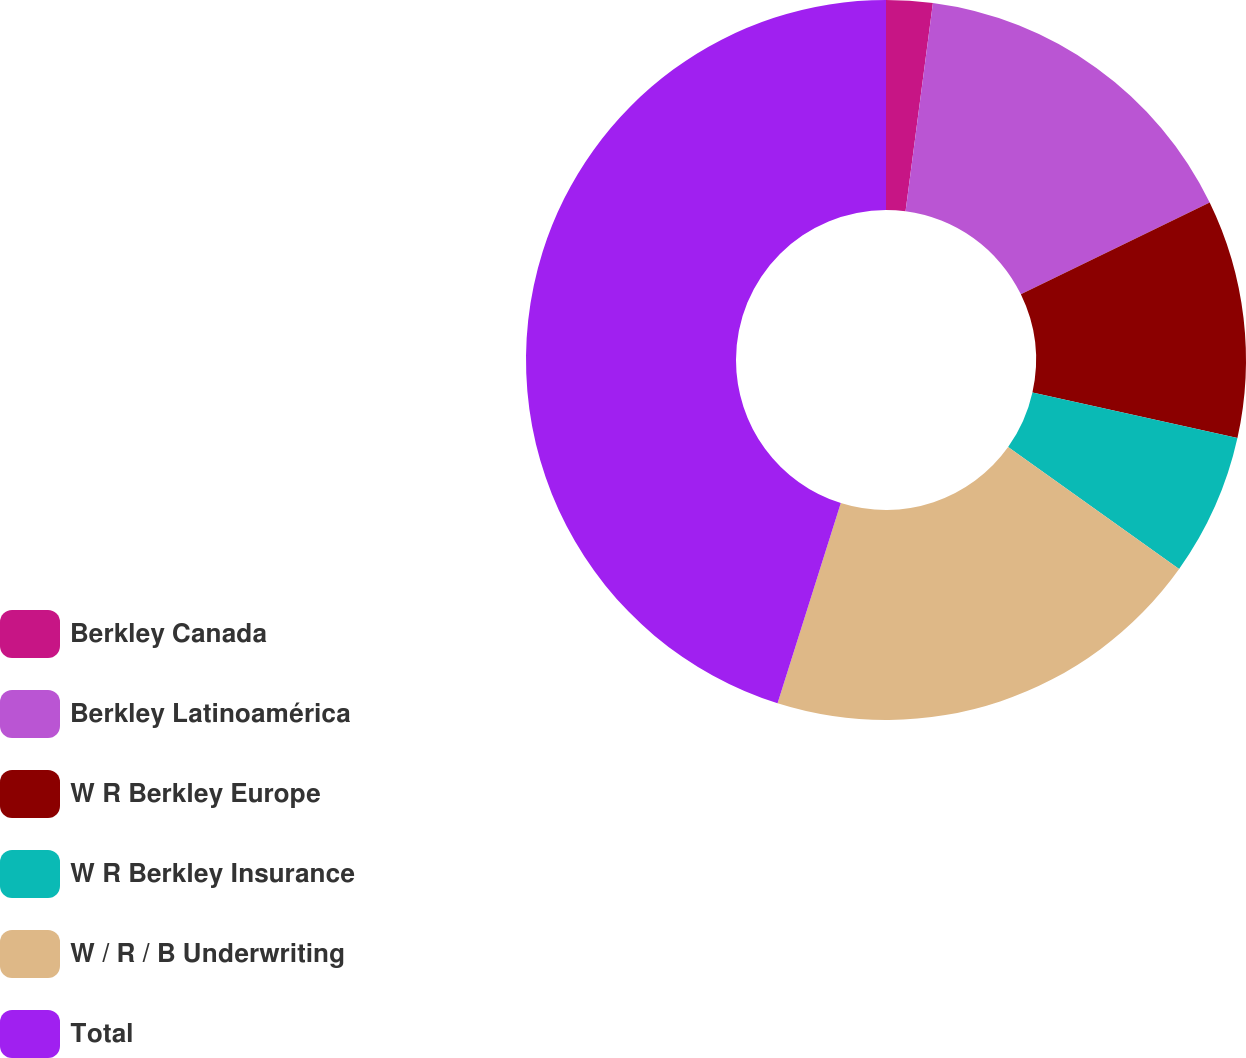Convert chart to OTSL. <chart><loc_0><loc_0><loc_500><loc_500><pie_chart><fcel>Berkley Canada<fcel>Berkley Latinoamérica<fcel>W R Berkley Europe<fcel>W R Berkley Insurance<fcel>W / R / B Underwriting<fcel>Total<nl><fcel>2.08%<fcel>15.71%<fcel>10.69%<fcel>6.38%<fcel>20.01%<fcel>45.13%<nl></chart> 